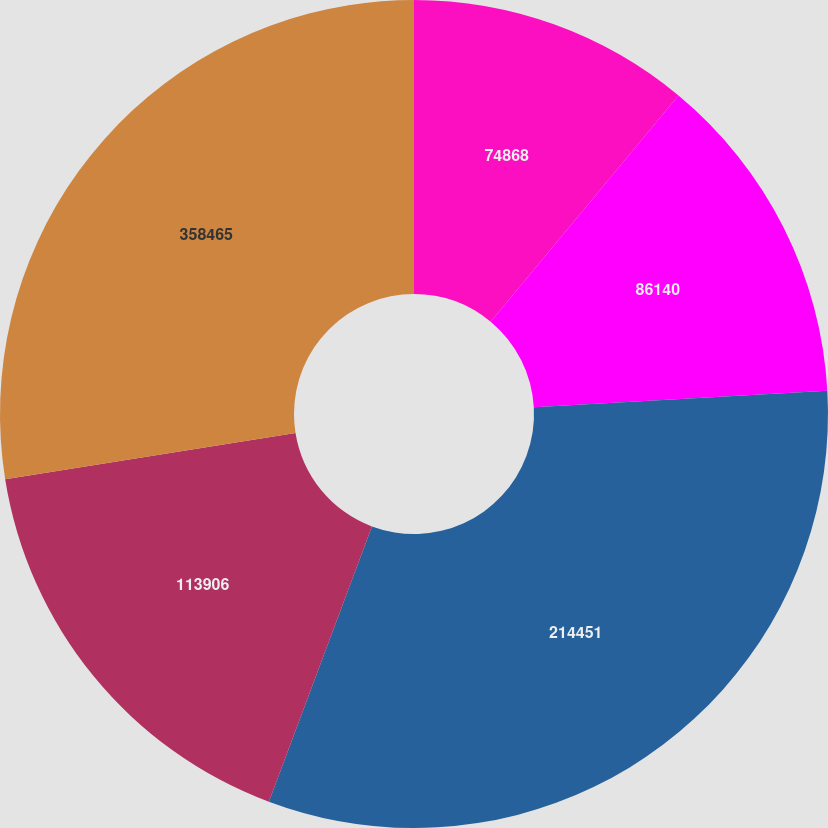Convert chart. <chart><loc_0><loc_0><loc_500><loc_500><pie_chart><fcel>74868<fcel>86140<fcel>214451<fcel>113906<fcel>358465<nl><fcel>11.03%<fcel>13.08%<fcel>31.59%<fcel>16.78%<fcel>27.52%<nl></chart> 